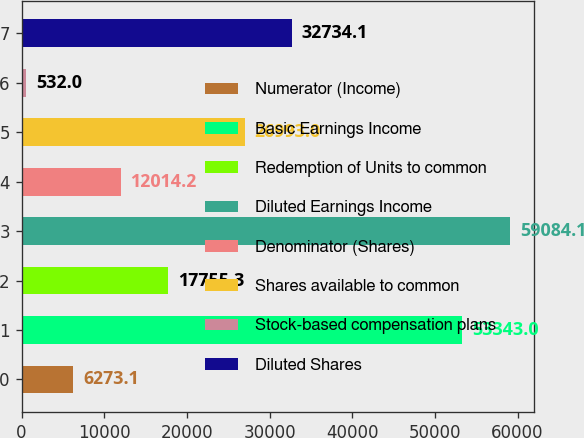Convert chart to OTSL. <chart><loc_0><loc_0><loc_500><loc_500><bar_chart><fcel>Numerator (Income)<fcel>Basic Earnings Income<fcel>Redemption of Units to common<fcel>Diluted Earnings Income<fcel>Denominator (Shares)<fcel>Shares available to common<fcel>Stock-based compensation plans<fcel>Diluted Shares<nl><fcel>6273.1<fcel>53343<fcel>17755.3<fcel>59084.1<fcel>12014.2<fcel>26993<fcel>532<fcel>32734.1<nl></chart> 